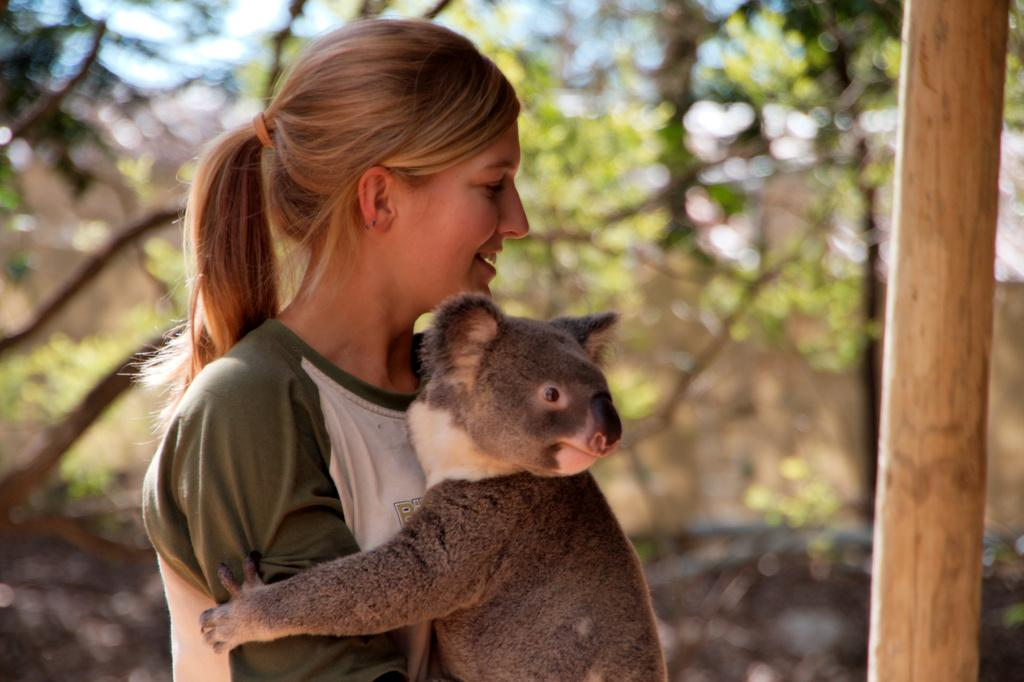Who is the main subject in the image? There is a girl in the image. What other living creature is present in the image? There is an animal in the image. What can be seen in the background of the image? There are trees in the background of the image. What object is located to the right side of the image? There is a pole to the right side of the image. What type of cake is the girl holding in the image? There is no cake present in the image; the girl is not holding any cake. 